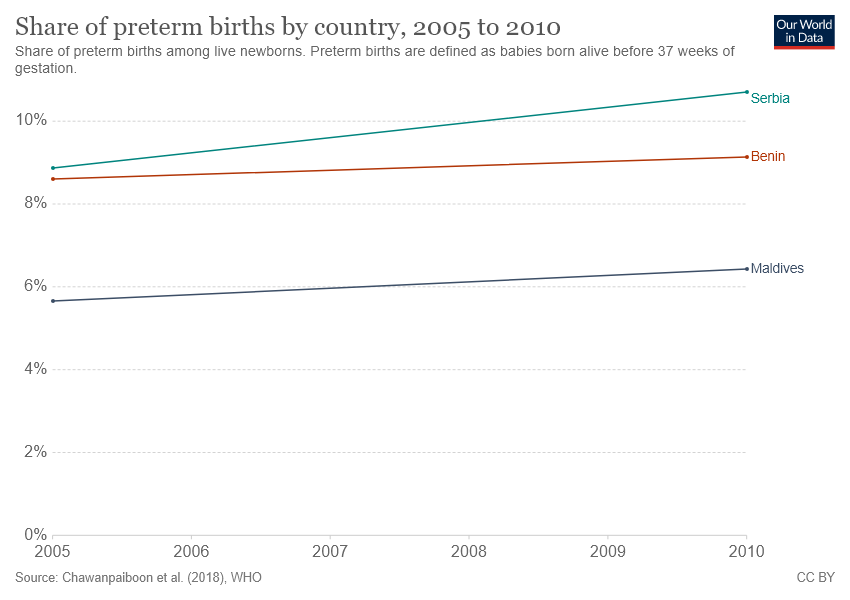Specify some key components in this picture. The gap between Benin and Serbia reached its biggest value in 2010. 